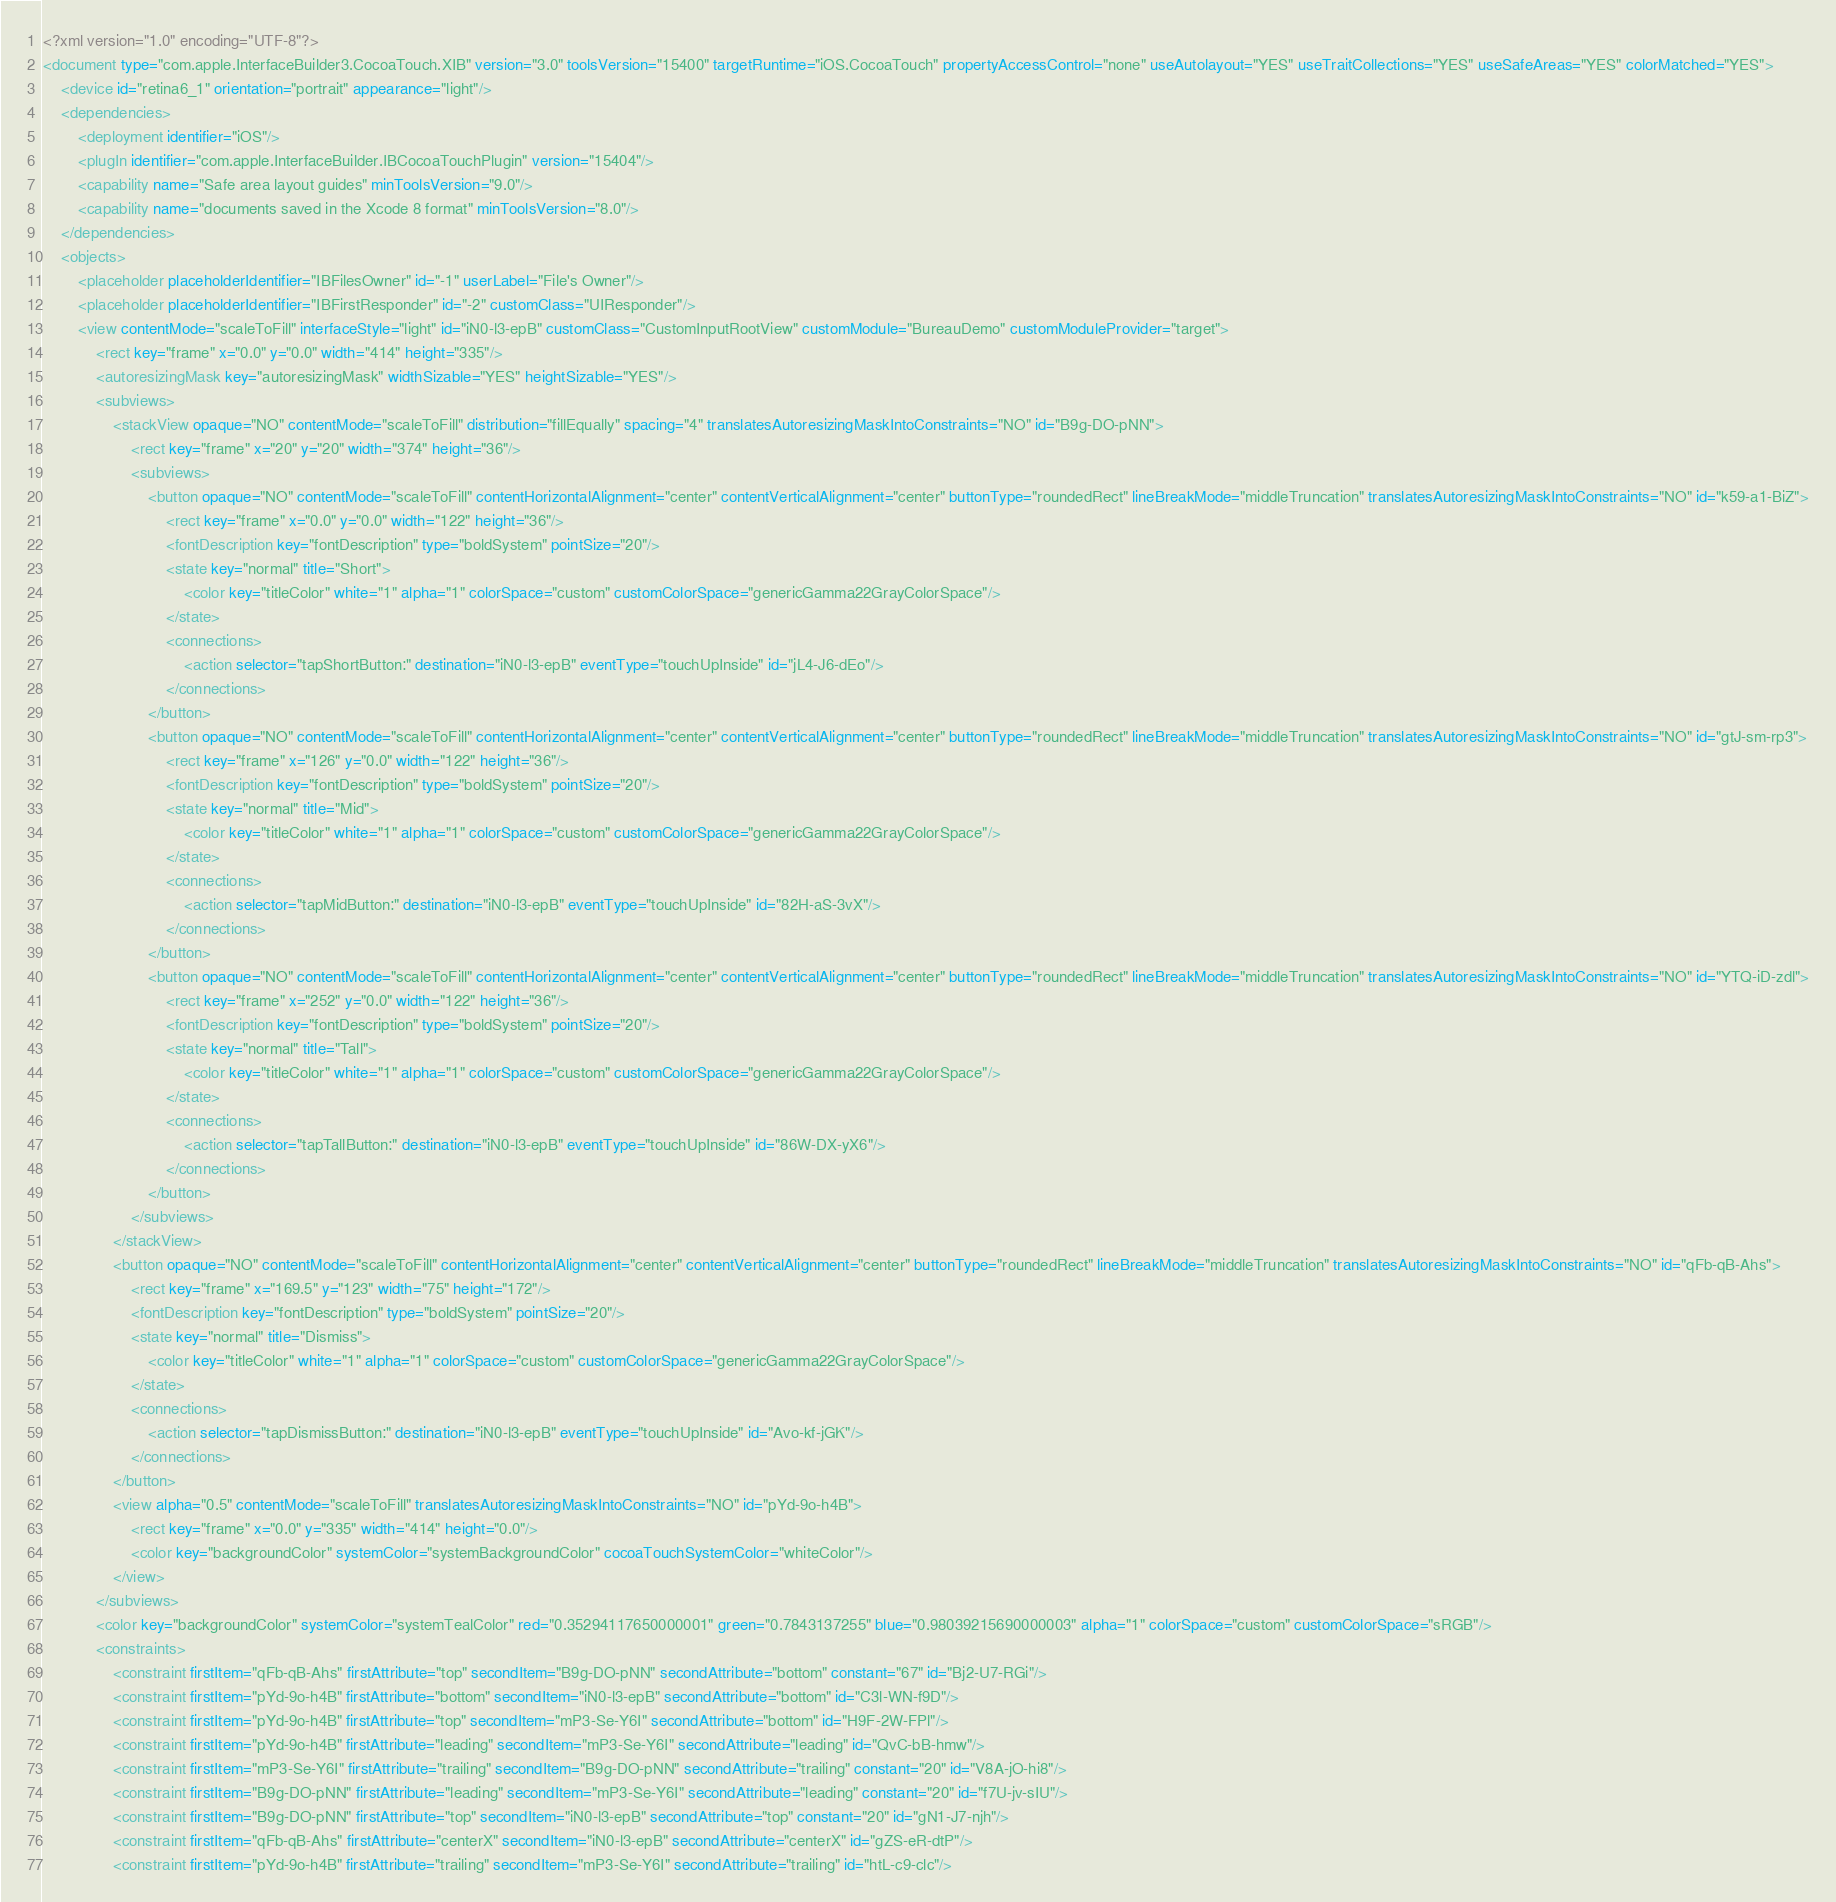Convert code to text. <code><loc_0><loc_0><loc_500><loc_500><_XML_><?xml version="1.0" encoding="UTF-8"?>
<document type="com.apple.InterfaceBuilder3.CocoaTouch.XIB" version="3.0" toolsVersion="15400" targetRuntime="iOS.CocoaTouch" propertyAccessControl="none" useAutolayout="YES" useTraitCollections="YES" useSafeAreas="YES" colorMatched="YES">
    <device id="retina6_1" orientation="portrait" appearance="light"/>
    <dependencies>
        <deployment identifier="iOS"/>
        <plugIn identifier="com.apple.InterfaceBuilder.IBCocoaTouchPlugin" version="15404"/>
        <capability name="Safe area layout guides" minToolsVersion="9.0"/>
        <capability name="documents saved in the Xcode 8 format" minToolsVersion="8.0"/>
    </dependencies>
    <objects>
        <placeholder placeholderIdentifier="IBFilesOwner" id="-1" userLabel="File's Owner"/>
        <placeholder placeholderIdentifier="IBFirstResponder" id="-2" customClass="UIResponder"/>
        <view contentMode="scaleToFill" interfaceStyle="light" id="iN0-l3-epB" customClass="CustomInputRootView" customModule="BureauDemo" customModuleProvider="target">
            <rect key="frame" x="0.0" y="0.0" width="414" height="335"/>
            <autoresizingMask key="autoresizingMask" widthSizable="YES" heightSizable="YES"/>
            <subviews>
                <stackView opaque="NO" contentMode="scaleToFill" distribution="fillEqually" spacing="4" translatesAutoresizingMaskIntoConstraints="NO" id="B9g-DO-pNN">
                    <rect key="frame" x="20" y="20" width="374" height="36"/>
                    <subviews>
                        <button opaque="NO" contentMode="scaleToFill" contentHorizontalAlignment="center" contentVerticalAlignment="center" buttonType="roundedRect" lineBreakMode="middleTruncation" translatesAutoresizingMaskIntoConstraints="NO" id="k59-a1-BiZ">
                            <rect key="frame" x="0.0" y="0.0" width="122" height="36"/>
                            <fontDescription key="fontDescription" type="boldSystem" pointSize="20"/>
                            <state key="normal" title="Short">
                                <color key="titleColor" white="1" alpha="1" colorSpace="custom" customColorSpace="genericGamma22GrayColorSpace"/>
                            </state>
                            <connections>
                                <action selector="tapShortButton:" destination="iN0-l3-epB" eventType="touchUpInside" id="jL4-J6-dEo"/>
                            </connections>
                        </button>
                        <button opaque="NO" contentMode="scaleToFill" contentHorizontalAlignment="center" contentVerticalAlignment="center" buttonType="roundedRect" lineBreakMode="middleTruncation" translatesAutoresizingMaskIntoConstraints="NO" id="gtJ-sm-rp3">
                            <rect key="frame" x="126" y="0.0" width="122" height="36"/>
                            <fontDescription key="fontDescription" type="boldSystem" pointSize="20"/>
                            <state key="normal" title="Mid">
                                <color key="titleColor" white="1" alpha="1" colorSpace="custom" customColorSpace="genericGamma22GrayColorSpace"/>
                            </state>
                            <connections>
                                <action selector="tapMidButton:" destination="iN0-l3-epB" eventType="touchUpInside" id="82H-aS-3vX"/>
                            </connections>
                        </button>
                        <button opaque="NO" contentMode="scaleToFill" contentHorizontalAlignment="center" contentVerticalAlignment="center" buttonType="roundedRect" lineBreakMode="middleTruncation" translatesAutoresizingMaskIntoConstraints="NO" id="YTQ-iD-zdl">
                            <rect key="frame" x="252" y="0.0" width="122" height="36"/>
                            <fontDescription key="fontDescription" type="boldSystem" pointSize="20"/>
                            <state key="normal" title="Tall">
                                <color key="titleColor" white="1" alpha="1" colorSpace="custom" customColorSpace="genericGamma22GrayColorSpace"/>
                            </state>
                            <connections>
                                <action selector="tapTallButton:" destination="iN0-l3-epB" eventType="touchUpInside" id="86W-DX-yX6"/>
                            </connections>
                        </button>
                    </subviews>
                </stackView>
                <button opaque="NO" contentMode="scaleToFill" contentHorizontalAlignment="center" contentVerticalAlignment="center" buttonType="roundedRect" lineBreakMode="middleTruncation" translatesAutoresizingMaskIntoConstraints="NO" id="qFb-qB-Ahs">
                    <rect key="frame" x="169.5" y="123" width="75" height="172"/>
                    <fontDescription key="fontDescription" type="boldSystem" pointSize="20"/>
                    <state key="normal" title="Dismiss">
                        <color key="titleColor" white="1" alpha="1" colorSpace="custom" customColorSpace="genericGamma22GrayColorSpace"/>
                    </state>
                    <connections>
                        <action selector="tapDismissButton:" destination="iN0-l3-epB" eventType="touchUpInside" id="Avo-kf-jGK"/>
                    </connections>
                </button>
                <view alpha="0.5" contentMode="scaleToFill" translatesAutoresizingMaskIntoConstraints="NO" id="pYd-9o-h4B">
                    <rect key="frame" x="0.0" y="335" width="414" height="0.0"/>
                    <color key="backgroundColor" systemColor="systemBackgroundColor" cocoaTouchSystemColor="whiteColor"/>
                </view>
            </subviews>
            <color key="backgroundColor" systemColor="systemTealColor" red="0.35294117650000001" green="0.7843137255" blue="0.98039215690000003" alpha="1" colorSpace="custom" customColorSpace="sRGB"/>
            <constraints>
                <constraint firstItem="qFb-qB-Ahs" firstAttribute="top" secondItem="B9g-DO-pNN" secondAttribute="bottom" constant="67" id="Bj2-U7-RGi"/>
                <constraint firstItem="pYd-9o-h4B" firstAttribute="bottom" secondItem="iN0-l3-epB" secondAttribute="bottom" id="C3l-WN-f9D"/>
                <constraint firstItem="pYd-9o-h4B" firstAttribute="top" secondItem="mP3-Se-Y6I" secondAttribute="bottom" id="H9F-2W-FPl"/>
                <constraint firstItem="pYd-9o-h4B" firstAttribute="leading" secondItem="mP3-Se-Y6I" secondAttribute="leading" id="QvC-bB-hmw"/>
                <constraint firstItem="mP3-Se-Y6I" firstAttribute="trailing" secondItem="B9g-DO-pNN" secondAttribute="trailing" constant="20" id="V8A-jO-hi8"/>
                <constraint firstItem="B9g-DO-pNN" firstAttribute="leading" secondItem="mP3-Se-Y6I" secondAttribute="leading" constant="20" id="f7U-jv-sIU"/>
                <constraint firstItem="B9g-DO-pNN" firstAttribute="top" secondItem="iN0-l3-epB" secondAttribute="top" constant="20" id="gN1-J7-njh"/>
                <constraint firstItem="qFb-qB-Ahs" firstAttribute="centerX" secondItem="iN0-l3-epB" secondAttribute="centerX" id="gZS-eR-dtP"/>
                <constraint firstItem="pYd-9o-h4B" firstAttribute="trailing" secondItem="mP3-Se-Y6I" secondAttribute="trailing" id="htL-c9-clc"/></code> 